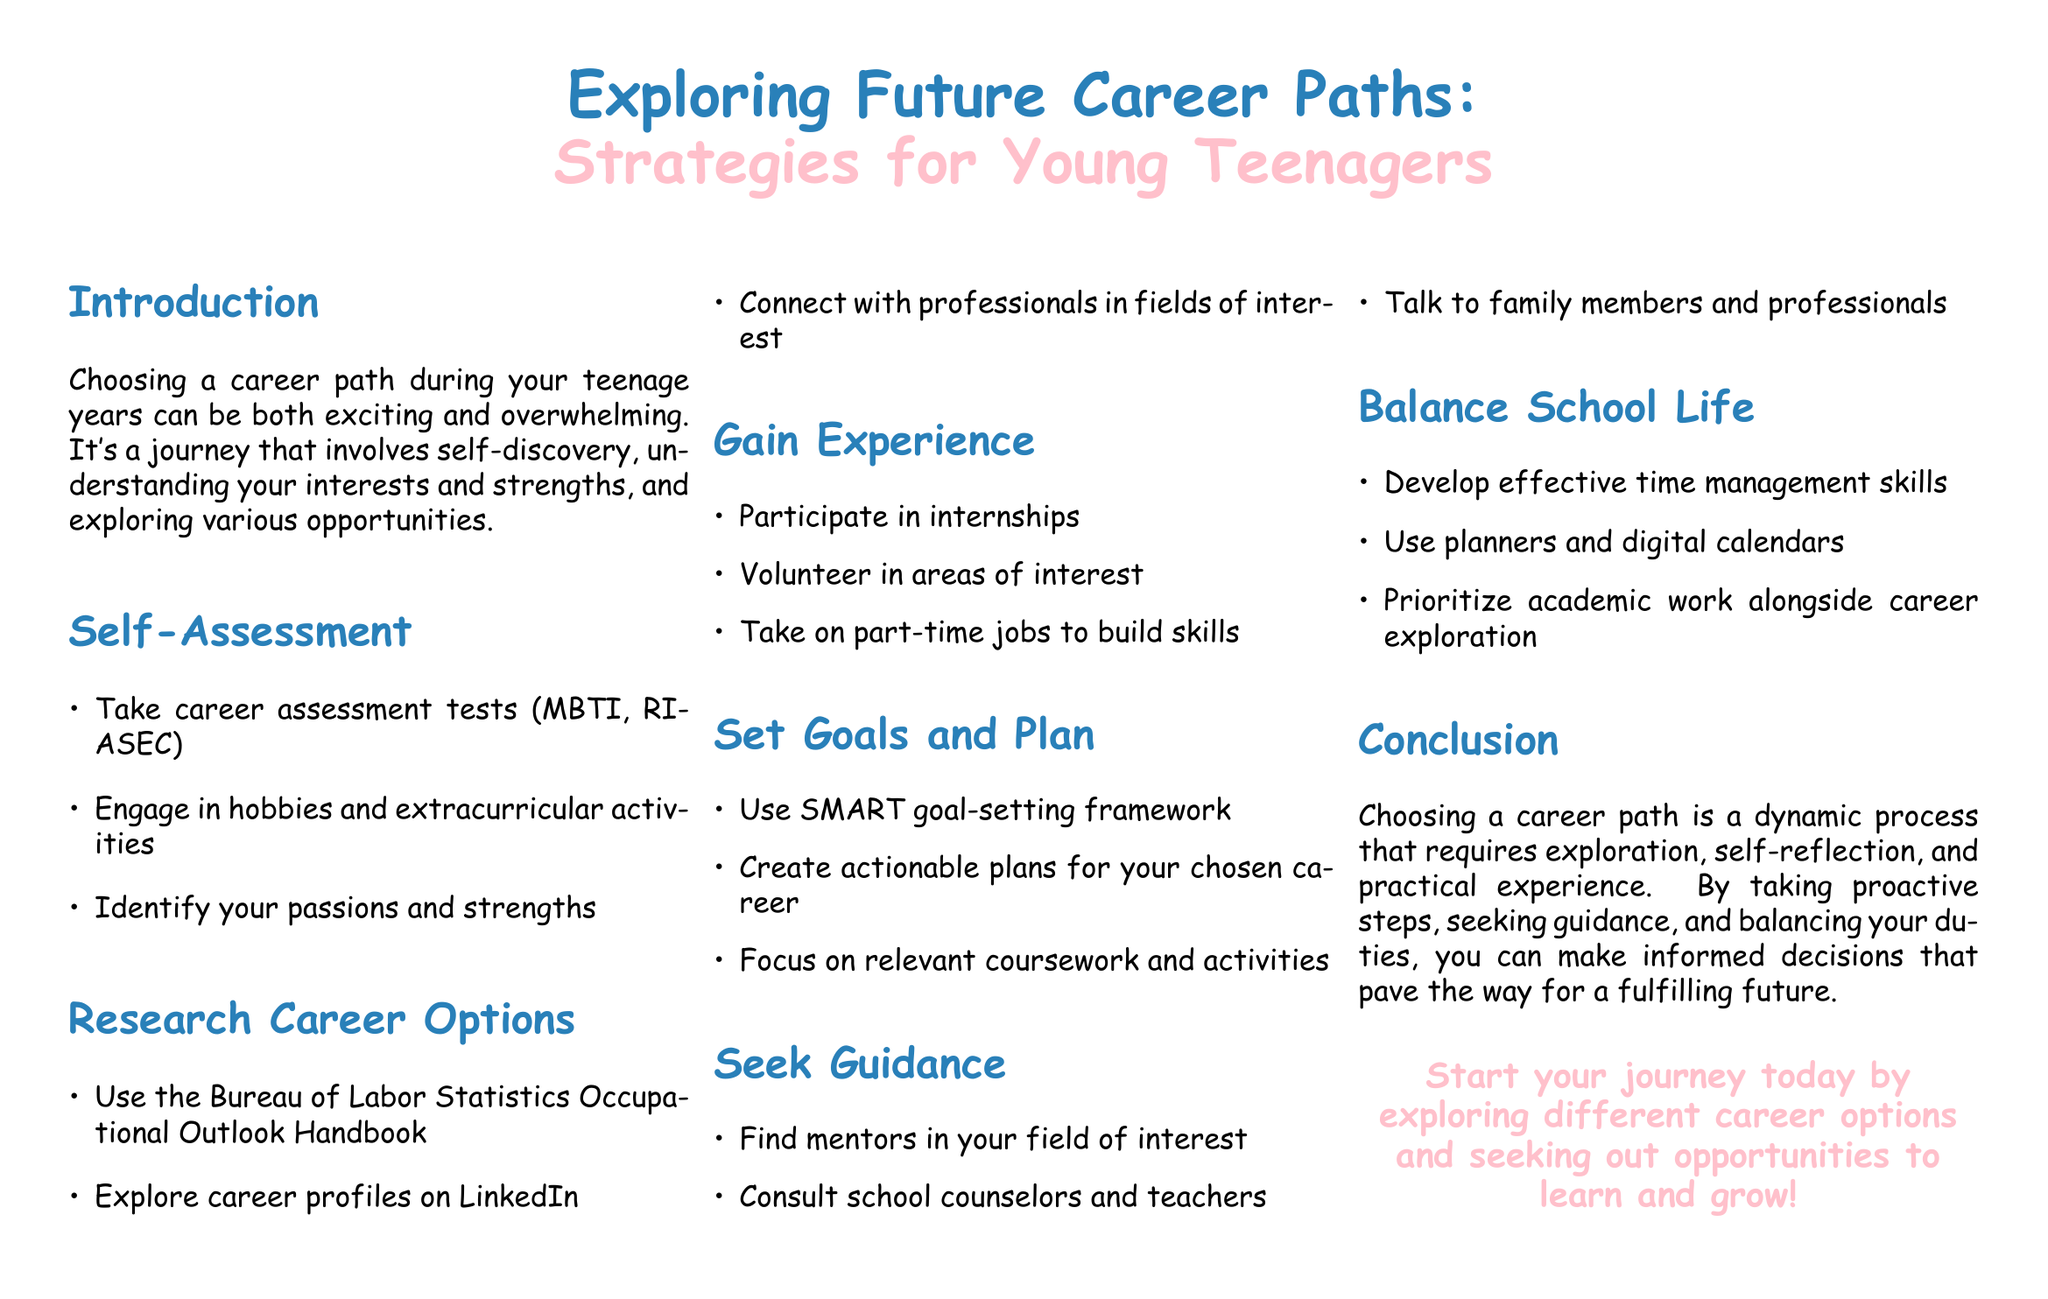What is the main focus of the document? The document focuses on strategies for young teenagers to explore career paths.
Answer: Strategies for young teenagers What is one tool suggested for self-assessment? The document mentions taking career assessment tests as a self-assessment tool.
Answer: Career assessment tests Which famous framework is used for goal-setting in the document? The document refers to the SMART goal-setting framework as a method for setting goals.
Answer: SMART What is a recommended way to gain experience? The document suggests participating in internships as a way to gain experience.
Answer: Internships Who should teenagers seek for guidance according to the document? The document encourages finding mentors in the field of interest for guidance.
Answer: Mentors 